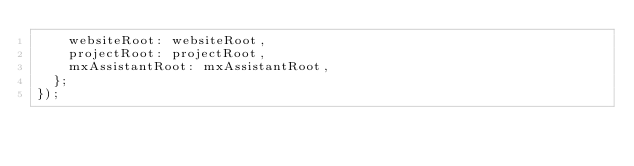<code> <loc_0><loc_0><loc_500><loc_500><_JavaScript_>    websiteRoot: websiteRoot,
    projectRoot: projectRoot,
    mxAssistantRoot: mxAssistantRoot,
  };
});
</code> 